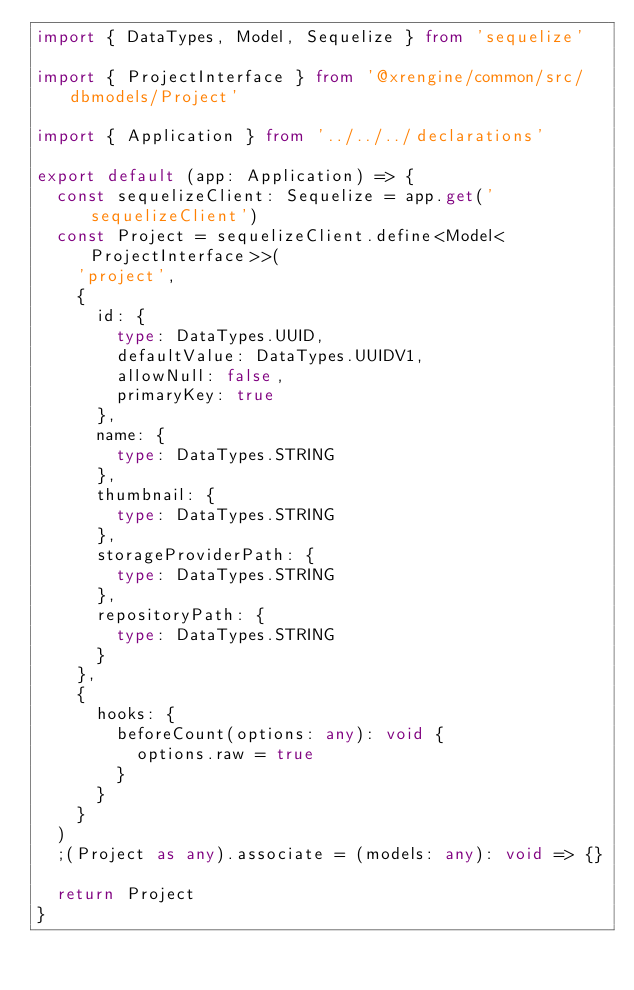<code> <loc_0><loc_0><loc_500><loc_500><_TypeScript_>import { DataTypes, Model, Sequelize } from 'sequelize'

import { ProjectInterface } from '@xrengine/common/src/dbmodels/Project'

import { Application } from '../../../declarations'

export default (app: Application) => {
  const sequelizeClient: Sequelize = app.get('sequelizeClient')
  const Project = sequelizeClient.define<Model<ProjectInterface>>(
    'project',
    {
      id: {
        type: DataTypes.UUID,
        defaultValue: DataTypes.UUIDV1,
        allowNull: false,
        primaryKey: true
      },
      name: {
        type: DataTypes.STRING
      },
      thumbnail: {
        type: DataTypes.STRING
      },
      storageProviderPath: {
        type: DataTypes.STRING
      },
      repositoryPath: {
        type: DataTypes.STRING
      }
    },
    {
      hooks: {
        beforeCount(options: any): void {
          options.raw = true
        }
      }
    }
  )
  ;(Project as any).associate = (models: any): void => {}

  return Project
}
</code> 